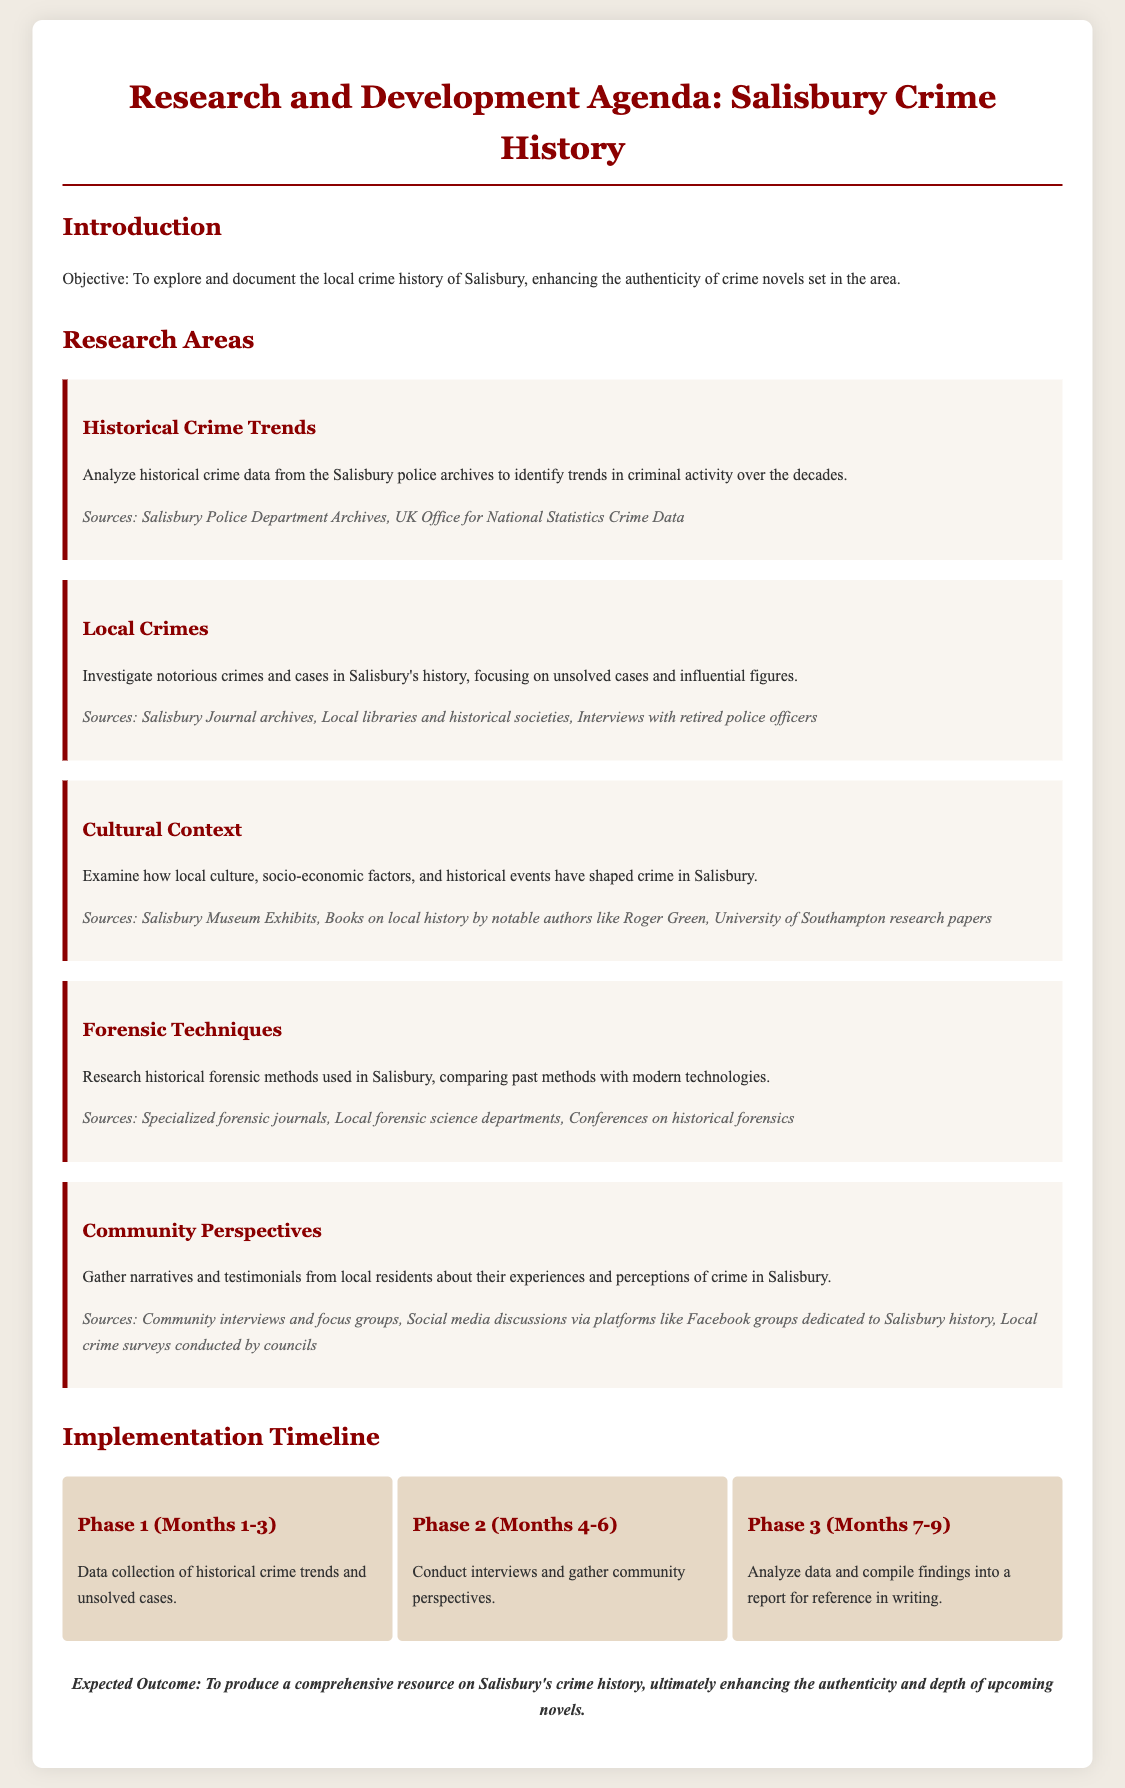What is the main objective of the research agenda? The objective is clearly stated as exploring and documenting the local crime history of Salisbury to enhance the authenticity of crime novels set in the area.
Answer: To explore and document the local crime history of Salisbury What is the first research area outlined in the document? The research areas are listed, and the first one is Historical Crime Trends.
Answer: Historical Crime Trends What sources are mentioned for analyzing historical crime trends? The document specifies sources including the Salisbury Police Department Archives and UK Office for National Statistics Crime Data for this area.
Answer: Salisbury Police Department Archives, UK Office for National Statistics Crime Data Which phase focuses on conducting interviews? The phases of the implementation timeline are described, with the second phase involving conducting interviews.
Answer: Phase 2 (Months 4-6) How many phases are outlined in the timeline? The implementation timeline consists of three distinct phases as indicated in the sections.
Answer: 3 What is the expected outcome of the research? The conclusion section states the expected outcome of producing a comprehensive resource on Salisbury's crime history.
Answer: To produce a comprehensive resource on Salisbury's crime history What cultural aspect is examined in the research areas? The document mentions examining how local culture, socio-economic factors, and historical events have shaped crime in Salisbury.
Answer: Local culture, socio-economic factors, historical events What is the total duration of the implementation timeline? By summing the months of each phase, the total duration extends from Month 1 to Month 9, making it 9 months long.
Answer: 9 months 